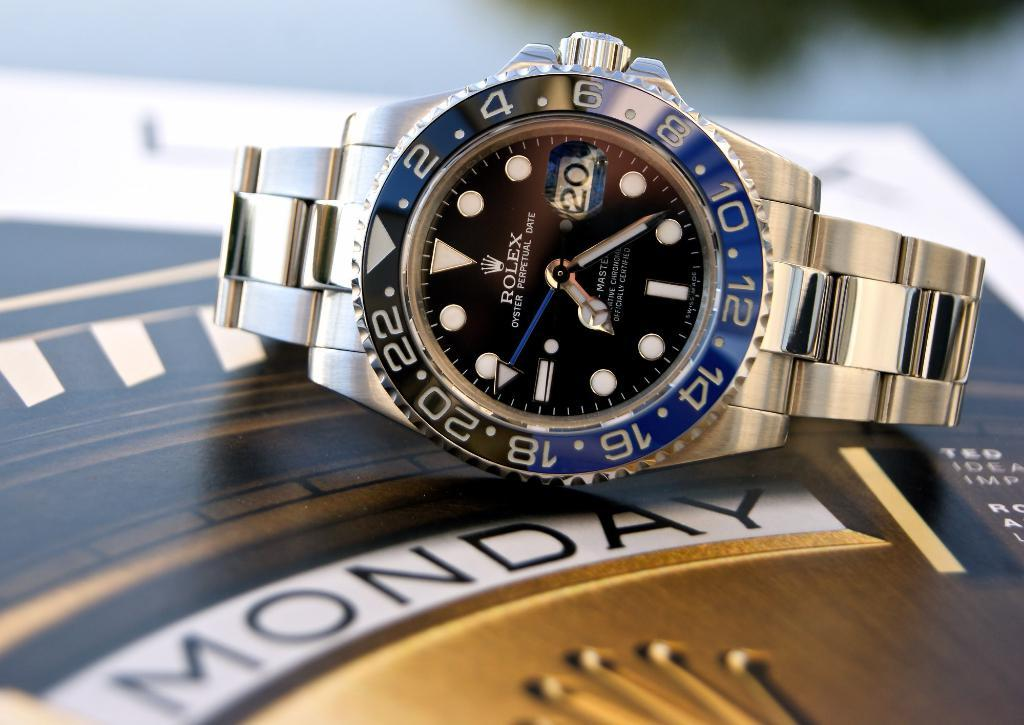<image>
Relay a brief, clear account of the picture shown. A Rolex watch that has the Oyster Perpetual Date on it. 